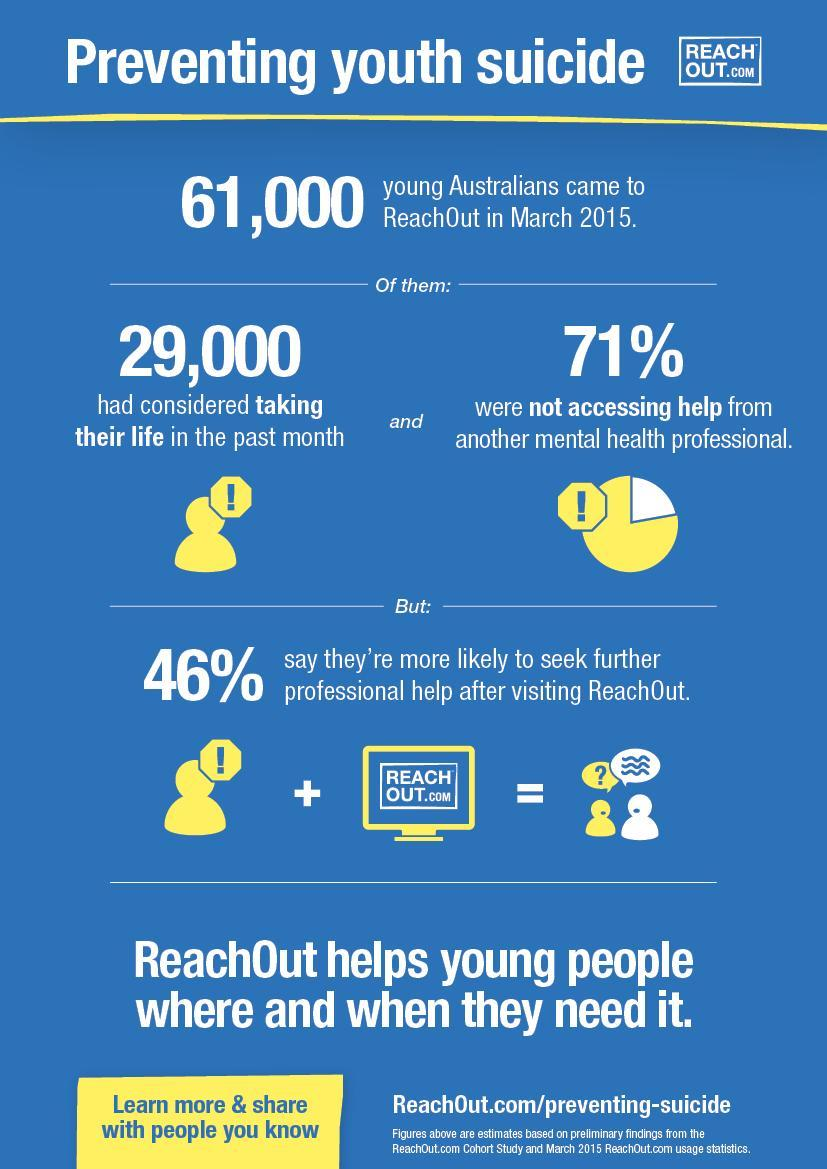What is written inside the image of a computer?
Answer the question with a short phrase. REACHOUT.com 